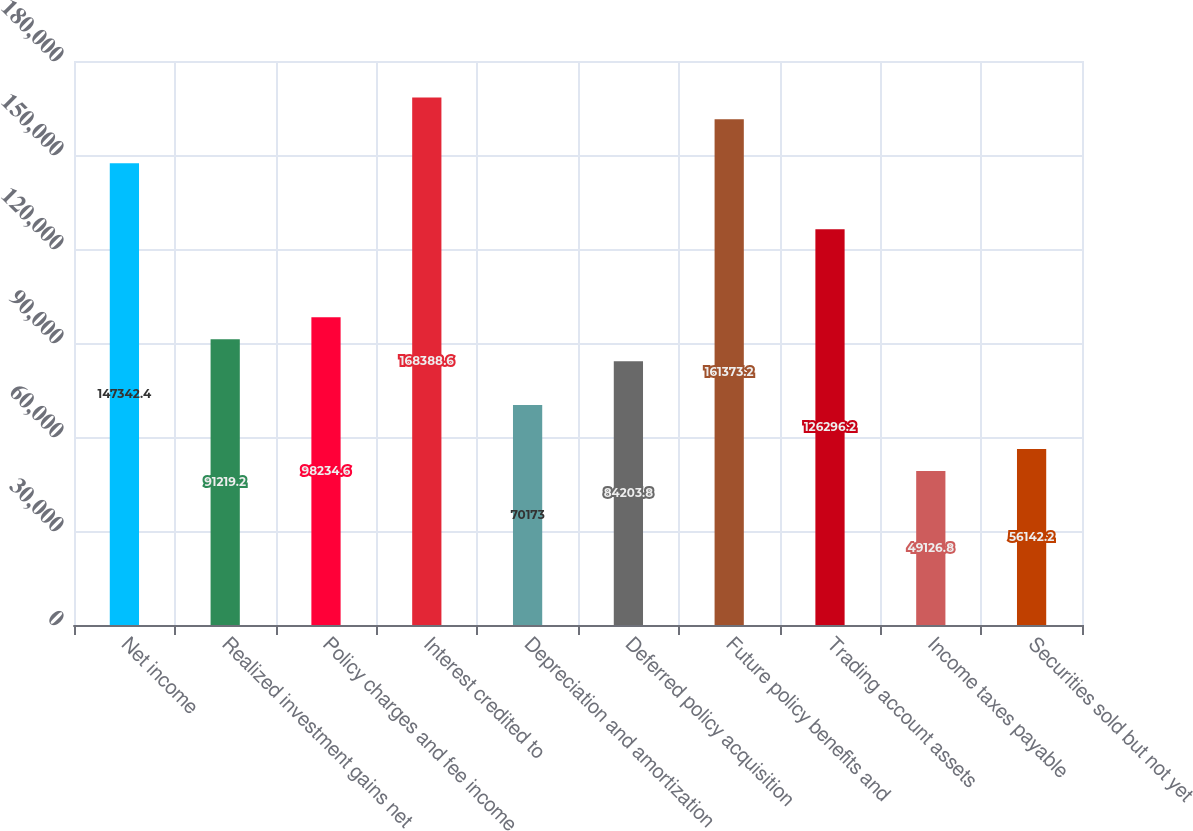Convert chart. <chart><loc_0><loc_0><loc_500><loc_500><bar_chart><fcel>Net income<fcel>Realized investment gains net<fcel>Policy charges and fee income<fcel>Interest credited to<fcel>Depreciation and amortization<fcel>Deferred policy acquisition<fcel>Future policy benefits and<fcel>Trading account assets<fcel>Income taxes payable<fcel>Securities sold but not yet<nl><fcel>147342<fcel>91219.2<fcel>98234.6<fcel>168389<fcel>70173<fcel>84203.8<fcel>161373<fcel>126296<fcel>49126.8<fcel>56142.2<nl></chart> 